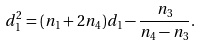<formula> <loc_0><loc_0><loc_500><loc_500>d _ { 1 } ^ { 2 } = ( n _ { 1 } + 2 n _ { 4 } ) d _ { 1 } - \frac { n _ { 3 } } { n _ { 4 } - n _ { 3 } } .</formula> 